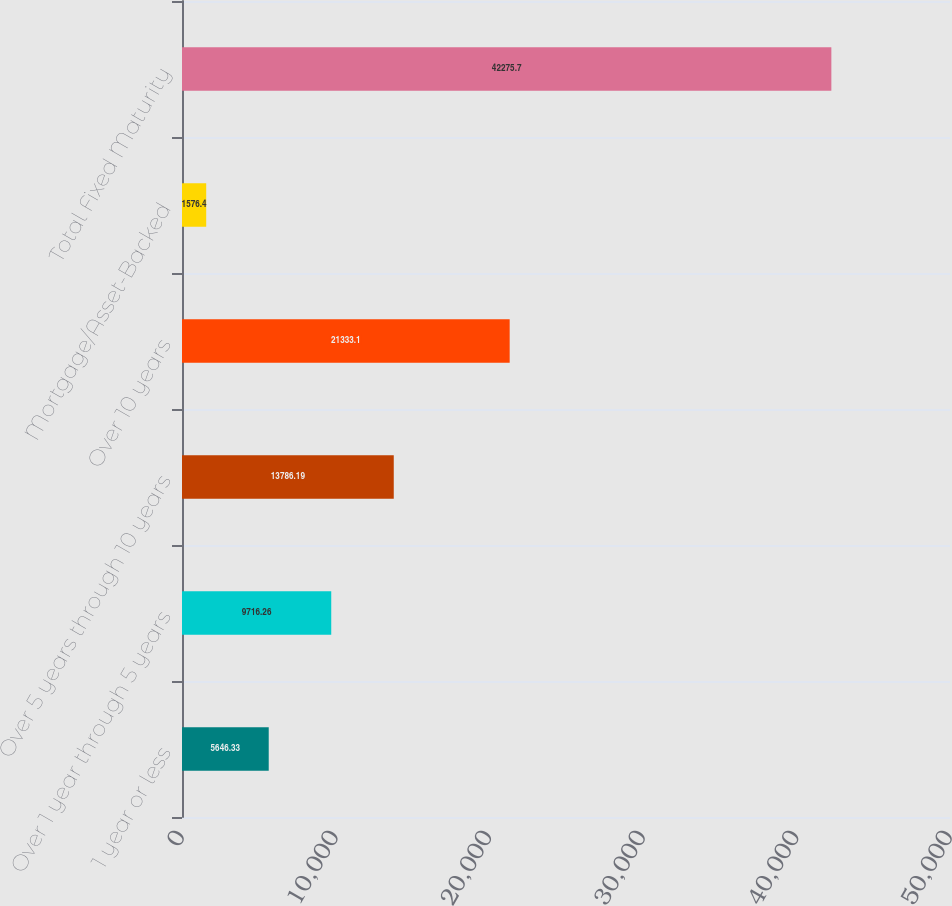<chart> <loc_0><loc_0><loc_500><loc_500><bar_chart><fcel>1 year or less<fcel>Over 1 year through 5 years<fcel>Over 5 years through 10 years<fcel>Over 10 years<fcel>Mortgage/Asset-Backed<fcel>Total Fixed Maturity<nl><fcel>5646.33<fcel>9716.26<fcel>13786.2<fcel>21333.1<fcel>1576.4<fcel>42275.7<nl></chart> 